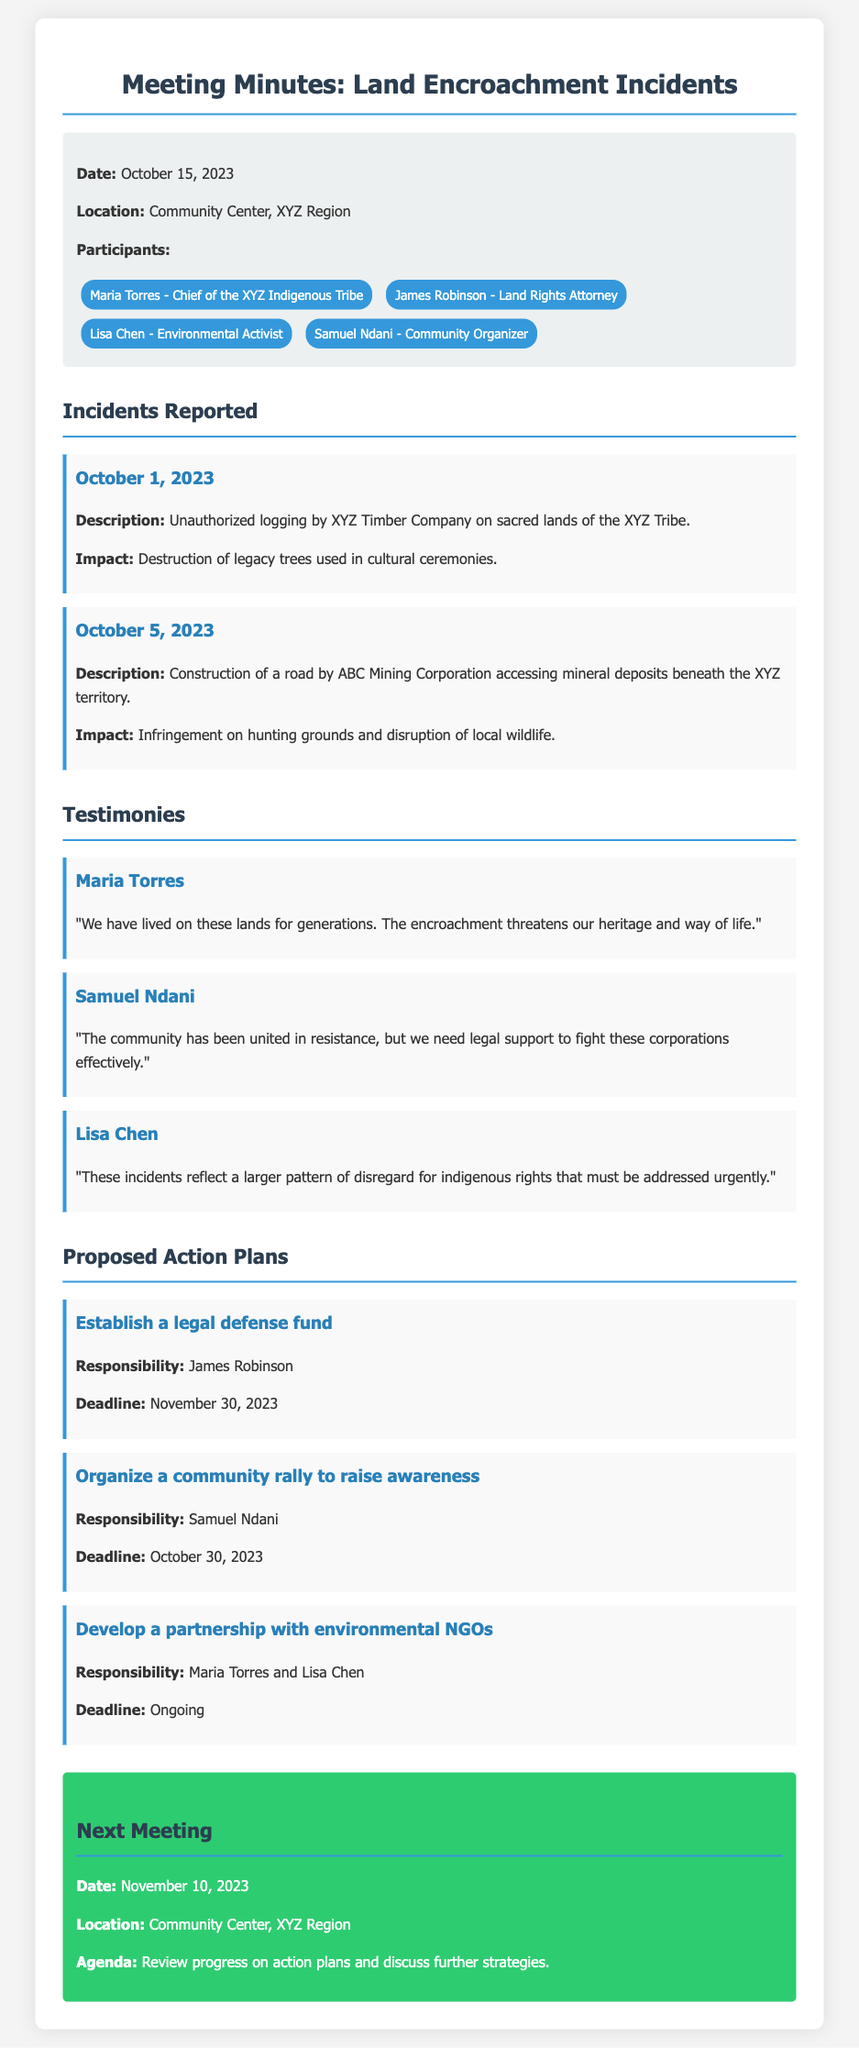What date was the meeting held? The date of the meeting is explicitly stated in the document as October 15, 2023.
Answer: October 15, 2023 Who is the Chief of the XYZ Indigenous Tribe? The document lists Maria Torres as the Chief of the XYZ Indigenous Tribe.
Answer: Maria Torres What was the first incident reported? The document details the first incident as unauthorized logging by XYZ Timber Company on sacred lands of the XYZ Tribe.
Answer: Unauthorized logging by XYZ Timber Company What impact did the logging incident have? The document states the impact was the destruction of legacy trees used in cultural ceremonies.
Answer: Destruction of legacy trees What is the deadline for establishing a legal defense fund? The document indicates that the deadline for this action is November 30, 2023.
Answer: November 30, 2023 Who is responsible for organizing a community rally? The responsibility for this action is assigned to Samuel Ndani as stated in the document.
Answer: Samuel Ndani What does Lisa Chen's testimony highlight? Lisa Chen's testimony emphasizes the larger pattern of disregard for indigenous rights.
Answer: Disregard for indigenous rights What is the purpose of the next meeting? The document specifies that the agenda for the next meeting is to review progress on action plans and discuss further strategies.
Answer: Review progress on action plans What is one of the action plans mentioned in the meeting? The document outlines several action plans, one being to develop a partnership with environmental NGOs.
Answer: Develop a partnership with environmental NGOs 